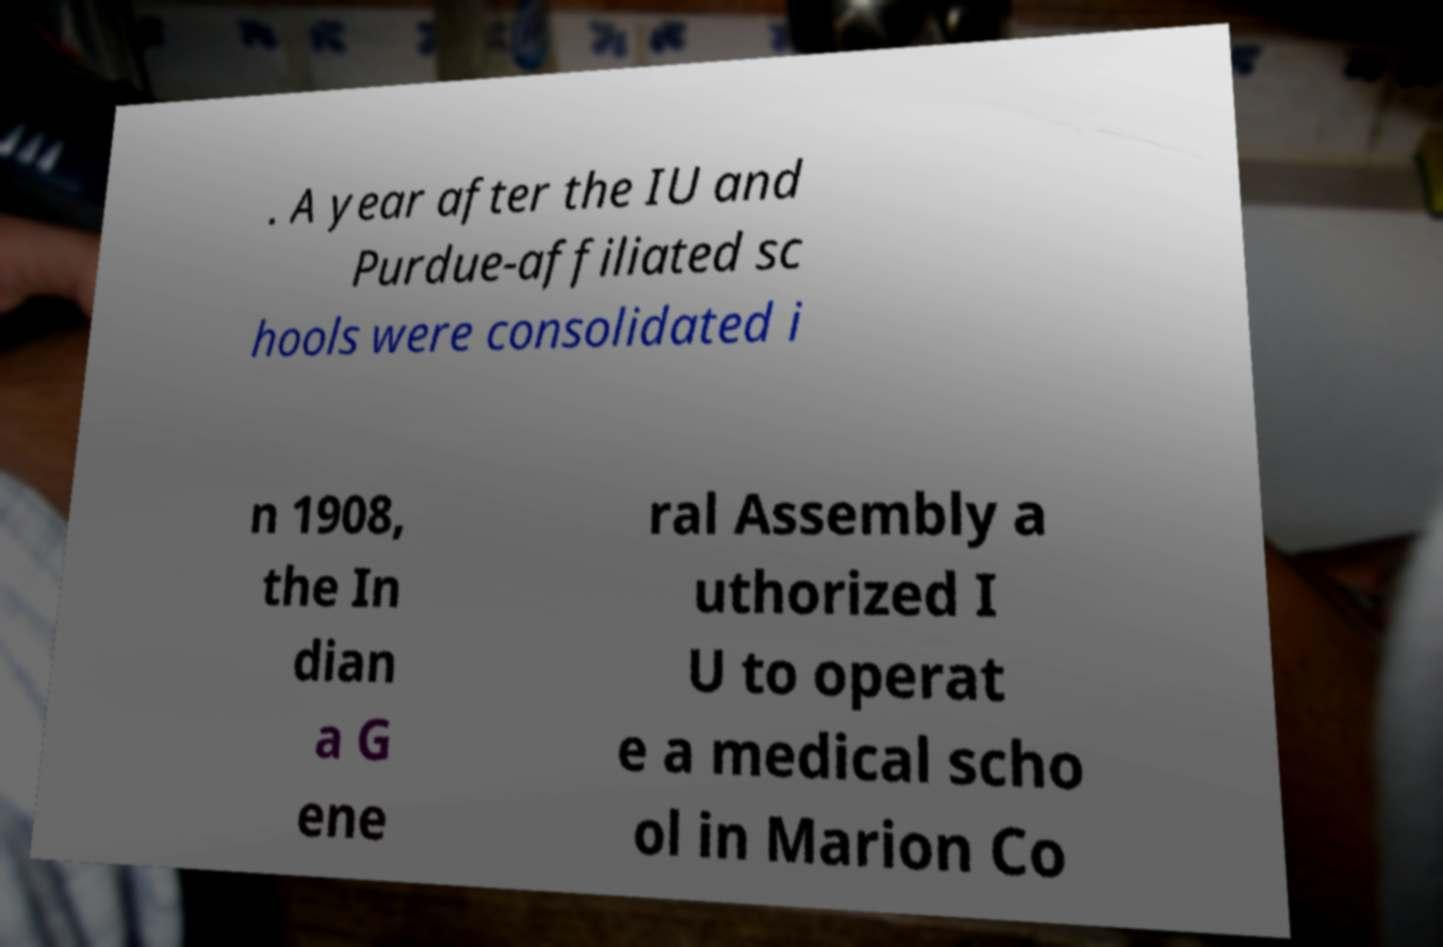Can you read and provide the text displayed in the image?This photo seems to have some interesting text. Can you extract and type it out for me? . A year after the IU and Purdue-affiliated sc hools were consolidated i n 1908, the In dian a G ene ral Assembly a uthorized I U to operat e a medical scho ol in Marion Co 